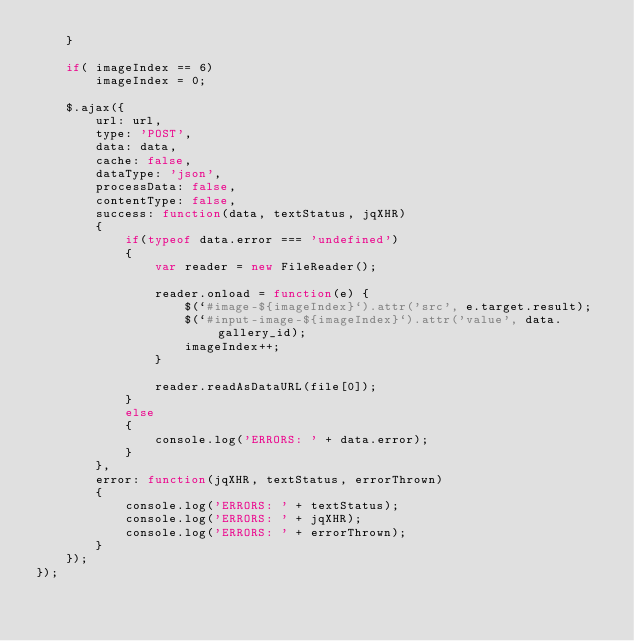Convert code to text. <code><loc_0><loc_0><loc_500><loc_500><_JavaScript_>    }

    if( imageIndex == 6)
        imageIndex = 0;

    $.ajax({
        url: url,
        type: 'POST',
        data: data,
        cache: false,
        dataType: 'json',
        processData: false, 
        contentType: false, 
        success: function(data, textStatus, jqXHR)
        {
            if(typeof data.error === 'undefined')
            {
                var reader = new FileReader();
  
                reader.onload = function(e) {
                    $(`#image-${imageIndex}`).attr('src', e.target.result);
                    $(`#input-image-${imageIndex}`).attr('value', data.gallery_id);
                    imageIndex++;
                }
            
                reader.readAsDataURL(file[0]);
            }
            else
            {
                console.log('ERRORS: ' + data.error);
            }
        },
        error: function(jqXHR, textStatus, errorThrown)
        {
            console.log('ERRORS: ' + textStatus);
            console.log('ERRORS: ' + jqXHR);
            console.log('ERRORS: ' + errorThrown);
        }
    });
});


</code> 